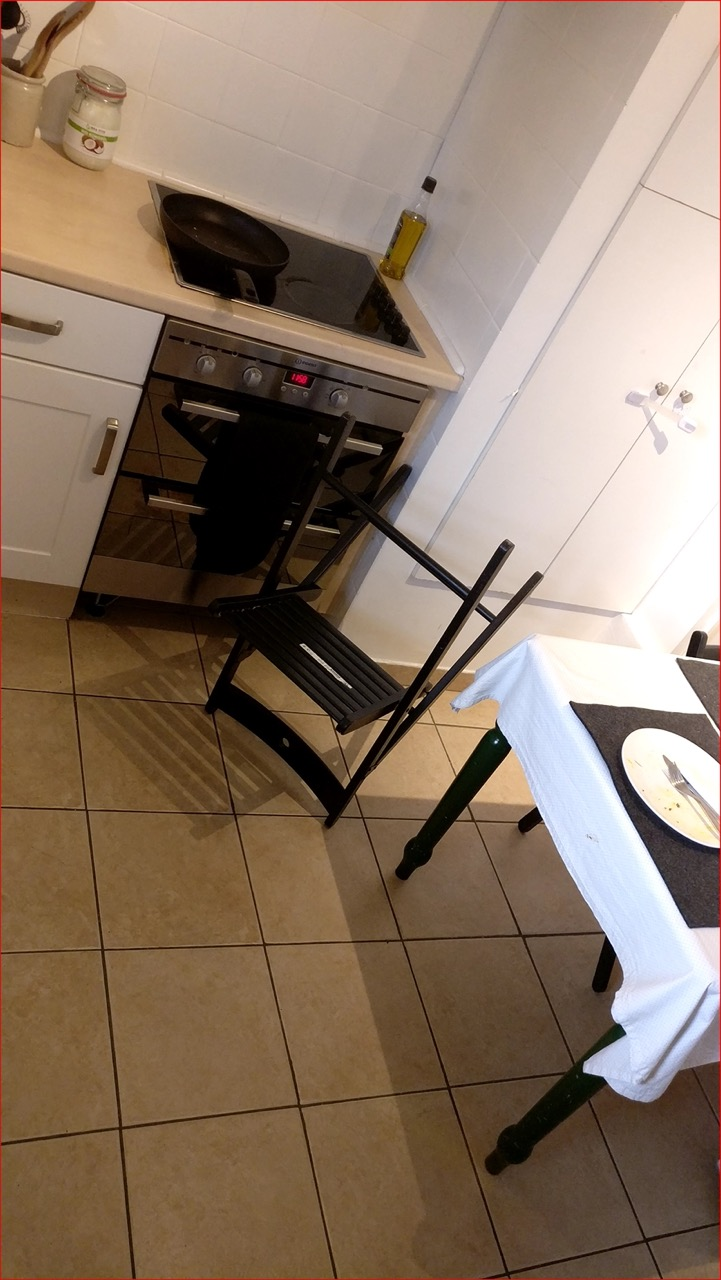Can you tell what might have been recently cooked or prepared in this kitchen? Based on the visible utensils and ingredients, it appears that someone might have recently used the frying pan, possibly for frying or sautéing. The presence of cooking oil and remnants of food on a plate on the table suggest a meal was recently prepared. 